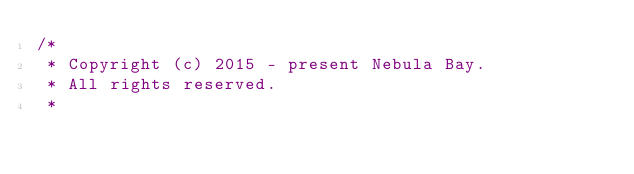<code> <loc_0><loc_0><loc_500><loc_500><_Java_>/*
 * Copyright (c) 2015 - present Nebula Bay.
 * All rights reserved.
 *</code> 